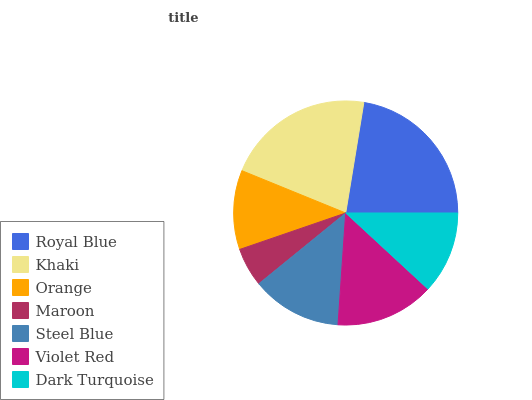Is Maroon the minimum?
Answer yes or no. Yes. Is Royal Blue the maximum?
Answer yes or no. Yes. Is Khaki the minimum?
Answer yes or no. No. Is Khaki the maximum?
Answer yes or no. No. Is Royal Blue greater than Khaki?
Answer yes or no. Yes. Is Khaki less than Royal Blue?
Answer yes or no. Yes. Is Khaki greater than Royal Blue?
Answer yes or no. No. Is Royal Blue less than Khaki?
Answer yes or no. No. Is Steel Blue the high median?
Answer yes or no. Yes. Is Steel Blue the low median?
Answer yes or no. Yes. Is Orange the high median?
Answer yes or no. No. Is Royal Blue the low median?
Answer yes or no. No. 